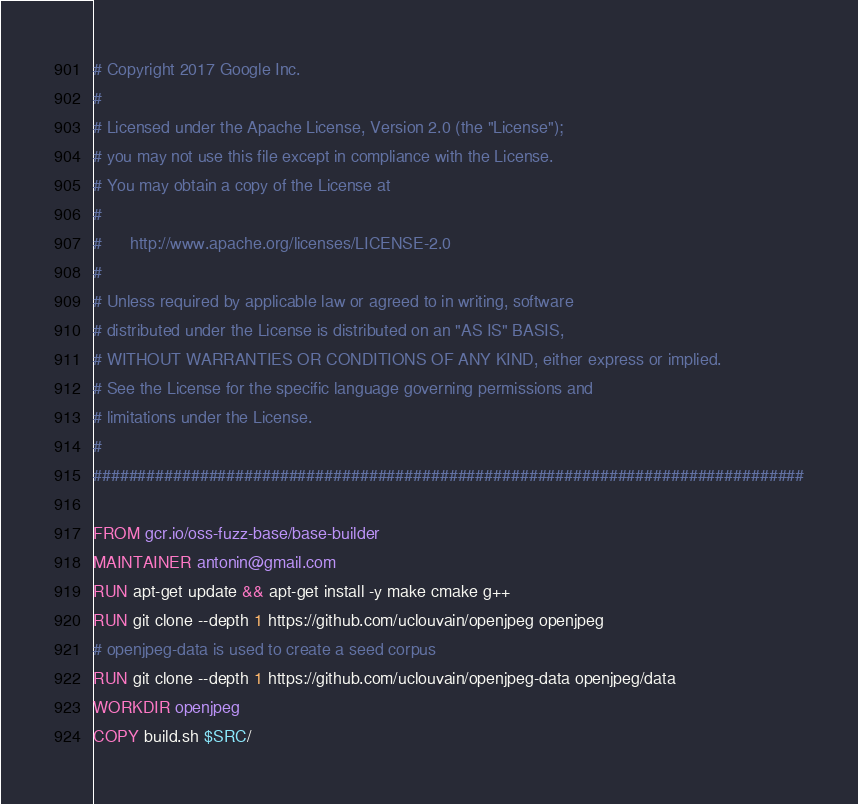<code> <loc_0><loc_0><loc_500><loc_500><_Dockerfile_># Copyright 2017 Google Inc.
#
# Licensed under the Apache License, Version 2.0 (the "License");
# you may not use this file except in compliance with the License.
# You may obtain a copy of the License at
#
#      http://www.apache.org/licenses/LICENSE-2.0
#
# Unless required by applicable law or agreed to in writing, software
# distributed under the License is distributed on an "AS IS" BASIS,
# WITHOUT WARRANTIES OR CONDITIONS OF ANY KIND, either express or implied.
# See the License for the specific language governing permissions and
# limitations under the License.
#
################################################################################

FROM gcr.io/oss-fuzz-base/base-builder
MAINTAINER antonin@gmail.com
RUN apt-get update && apt-get install -y make cmake g++
RUN git clone --depth 1 https://github.com/uclouvain/openjpeg openjpeg
# openjpeg-data is used to create a seed corpus
RUN git clone --depth 1 https://github.com/uclouvain/openjpeg-data openjpeg/data
WORKDIR openjpeg
COPY build.sh $SRC/
</code> 